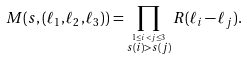Convert formula to latex. <formula><loc_0><loc_0><loc_500><loc_500>M ( s , ( \ell _ { 1 } , \ell _ { 2 } , \ell _ { 3 } ) ) = \prod _ { \stackrel { 1 \leq i < j \leq 3 } { s ( i ) > s ( j ) } } R ( \ell _ { i } - \ell _ { j } ) .</formula> 